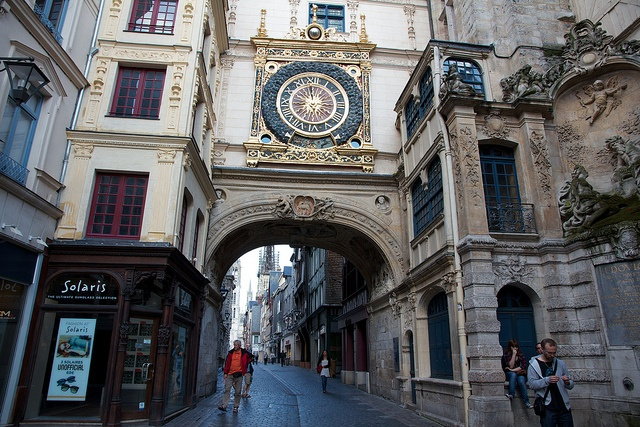Describe the objects in this image and their specific colors. I can see clock in black, gray, ivory, darkgray, and blue tones, people in black, gray, and blue tones, people in black, gray, maroon, and brown tones, people in black, navy, gray, and blue tones, and people in black, gray, and navy tones in this image. 